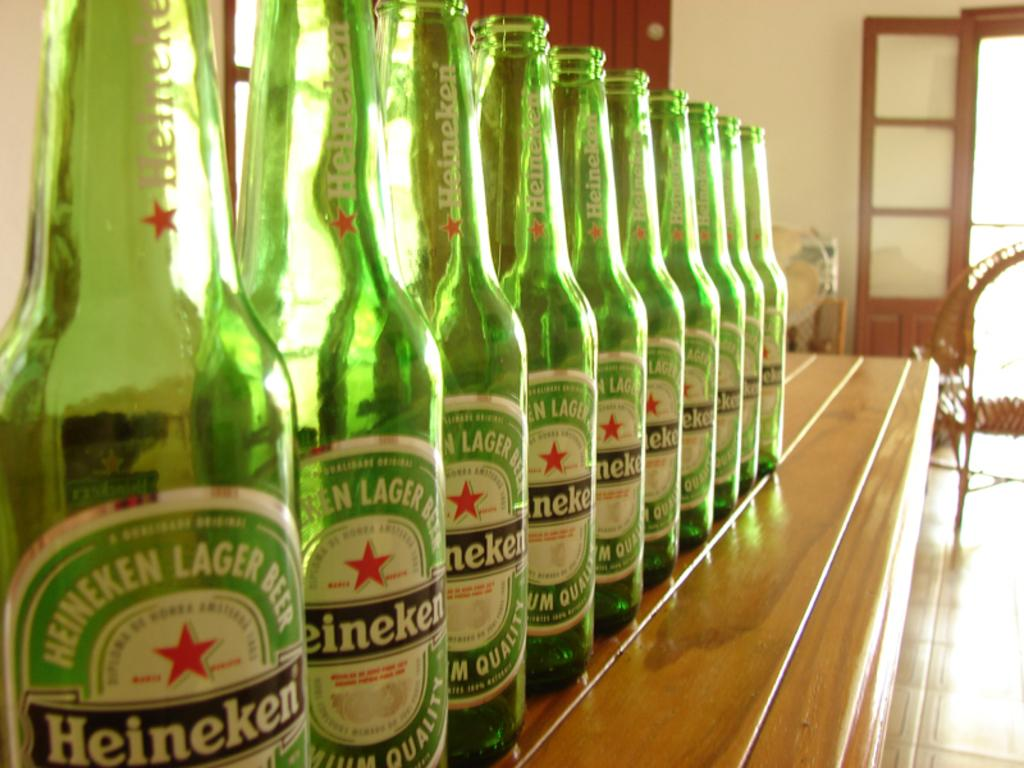<image>
Give a short and clear explanation of the subsequent image. A line of Heineken bottles are on a table. 